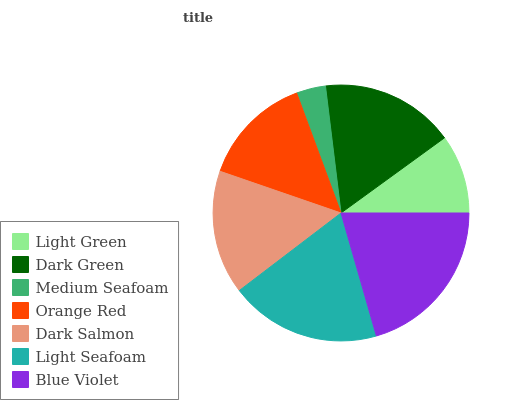Is Medium Seafoam the minimum?
Answer yes or no. Yes. Is Blue Violet the maximum?
Answer yes or no. Yes. Is Dark Green the minimum?
Answer yes or no. No. Is Dark Green the maximum?
Answer yes or no. No. Is Dark Green greater than Light Green?
Answer yes or no. Yes. Is Light Green less than Dark Green?
Answer yes or no. Yes. Is Light Green greater than Dark Green?
Answer yes or no. No. Is Dark Green less than Light Green?
Answer yes or no. No. Is Dark Salmon the high median?
Answer yes or no. Yes. Is Dark Salmon the low median?
Answer yes or no. Yes. Is Light Green the high median?
Answer yes or no. No. Is Orange Red the low median?
Answer yes or no. No. 